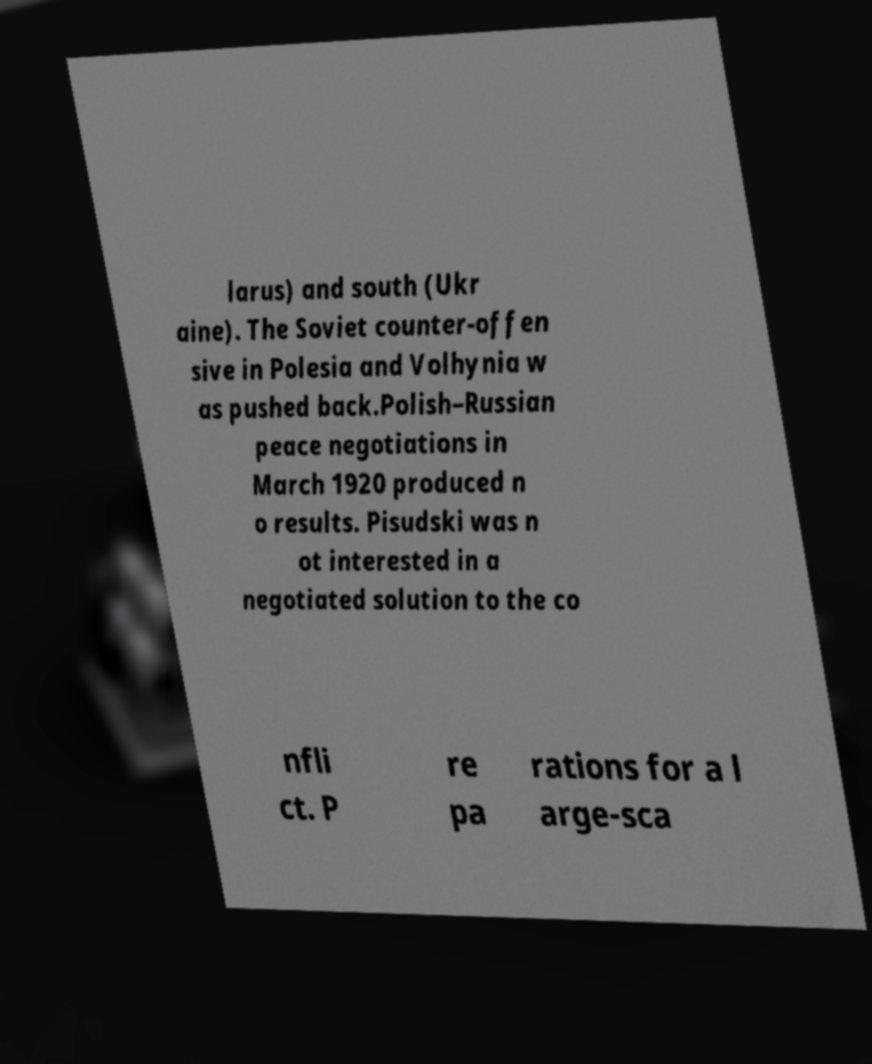Please identify and transcribe the text found in this image. larus) and south (Ukr aine). The Soviet counter-offen sive in Polesia and Volhynia w as pushed back.Polish–Russian peace negotiations in March 1920 produced n o results. Pisudski was n ot interested in a negotiated solution to the co nfli ct. P re pa rations for a l arge-sca 